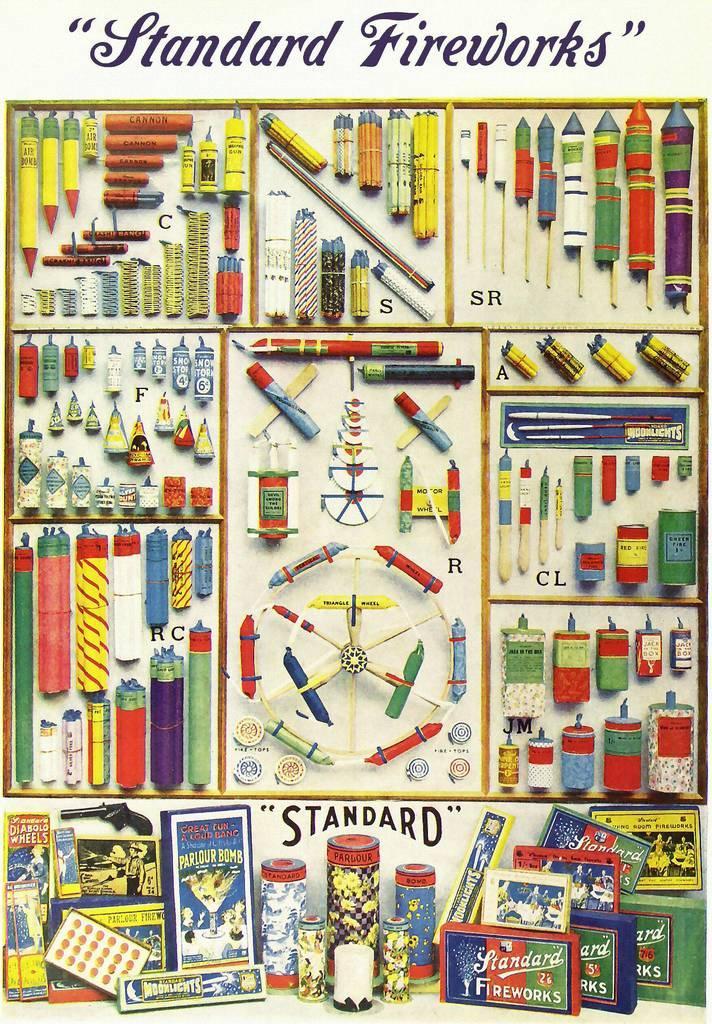<image>
Render a clear and concise summary of the photo. A poster that reads standard fireworks on the top with several illustrations below. 